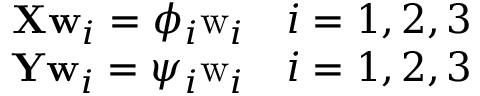Convert formula to latex. <formula><loc_0><loc_0><loc_500><loc_500>\begin{array} { r } { X w _ { i } = \phi _ { i } w _ { i } \quad i = { 1 , 2 , 3 } } \\ { Y w _ { i } = \psi _ { i } w _ { i } \quad i = { 1 , 2 , 3 } } \end{array}</formula> 